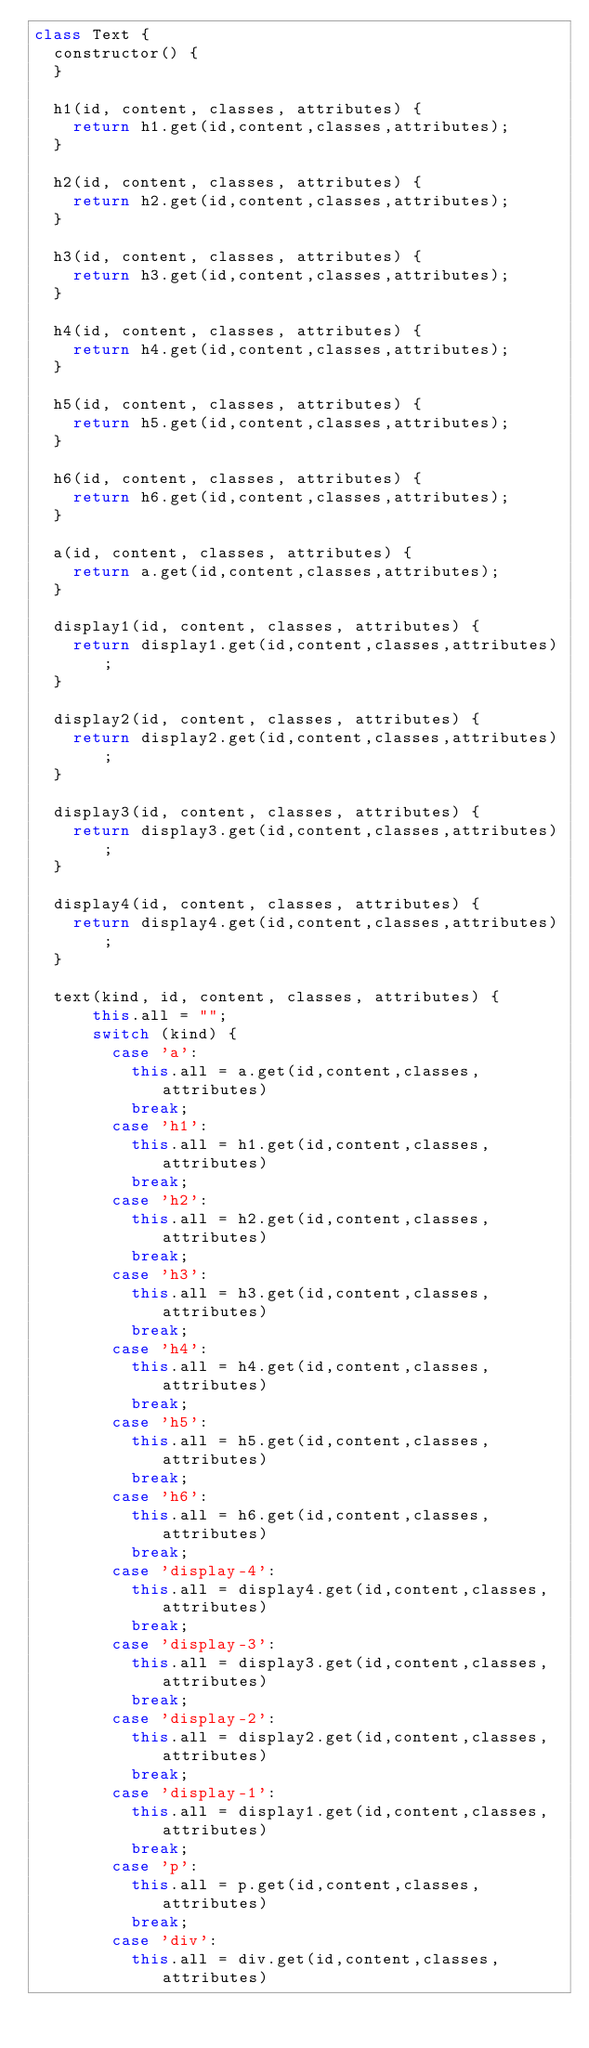<code> <loc_0><loc_0><loc_500><loc_500><_JavaScript_>class Text {
  constructor() {
  }

  h1(id, content, classes, attributes) {
    return h1.get(id,content,classes,attributes);
  }

  h2(id, content, classes, attributes) {
    return h2.get(id,content,classes,attributes);
  }

  h3(id, content, classes, attributes) {
    return h3.get(id,content,classes,attributes);
  }

  h4(id, content, classes, attributes) {
    return h4.get(id,content,classes,attributes);
  }

  h5(id, content, classes, attributes) {
    return h5.get(id,content,classes,attributes);
  }

  h6(id, content, classes, attributes) {
    return h6.get(id,content,classes,attributes);
  }

  a(id, content, classes, attributes) {
    return a.get(id,content,classes,attributes);
  }

  display1(id, content, classes, attributes) {
    return display1.get(id,content,classes,attributes);
  }

  display2(id, content, classes, attributes) {
    return display2.get(id,content,classes,attributes);
  }

  display3(id, content, classes, attributes) {
    return display3.get(id,content,classes,attributes);
  }

  display4(id, content, classes, attributes) {
    return display4.get(id,content,classes,attributes);
  }

  text(kind, id, content, classes, attributes) {
      this.all = "";
      switch (kind) {
        case 'a':
          this.all = a.get(id,content,classes,attributes)
          break;
        case 'h1':
          this.all = h1.get(id,content,classes,attributes)
          break;
        case 'h2':
          this.all = h2.get(id,content,classes,attributes)
          break;
        case 'h3':
          this.all = h3.get(id,content,classes,attributes)
          break;
        case 'h4':
          this.all = h4.get(id,content,classes,attributes)
          break;
        case 'h5':
          this.all = h5.get(id,content,classes,attributes)
          break;
        case 'h6':
          this.all = h6.get(id,content,classes,attributes)
          break;
        case 'display-4':
          this.all = display4.get(id,content,classes,attributes)
          break;
        case 'display-3':
          this.all = display3.get(id,content,classes,attributes)
          break;
        case 'display-2':
          this.all = display2.get(id,content,classes,attributes)
          break;
        case 'display-1':
          this.all = display1.get(id,content,classes,attributes)
          break;
        case 'p':
          this.all = p.get(id,content,classes,attributes)
          break;
        case 'div':
          this.all = div.get(id,content,classes,attributes)</code> 